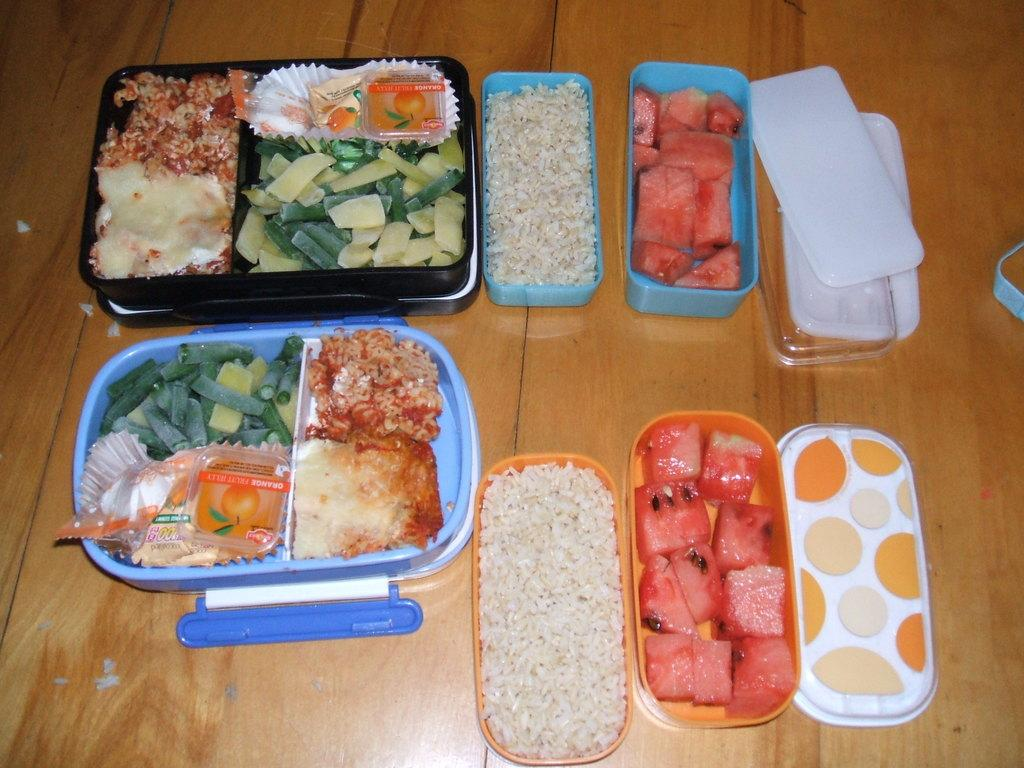What type of surface is visible in the image? There is a wooden platform in the image. What items are placed on the wooden platform? Boxes, food, and fruits are present on the wooden platform. Are there any other objects on the wooden platform? Yes, there are other objects on the wooden platform. What type of linen can be seen draped over the boxes in the image? There is no linen present in the image; it only features a wooden platform with various items on it. 